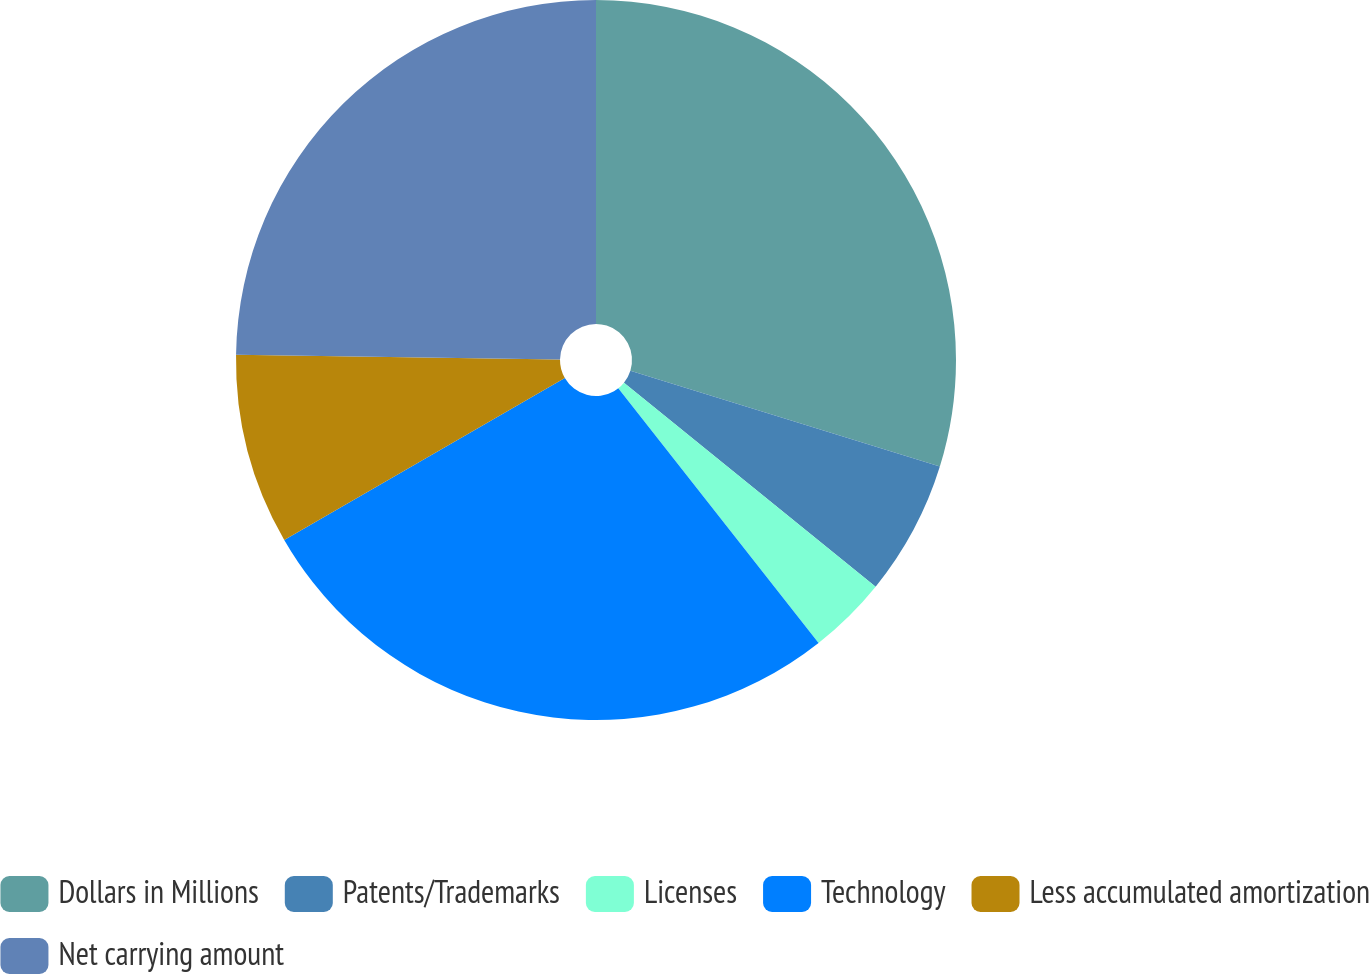<chart> <loc_0><loc_0><loc_500><loc_500><pie_chart><fcel>Dollars in Millions<fcel>Patents/Trademarks<fcel>Licenses<fcel>Technology<fcel>Less accumulated amortization<fcel>Net carrying amount<nl><fcel>29.79%<fcel>6.06%<fcel>3.55%<fcel>27.28%<fcel>8.57%<fcel>24.77%<nl></chart> 